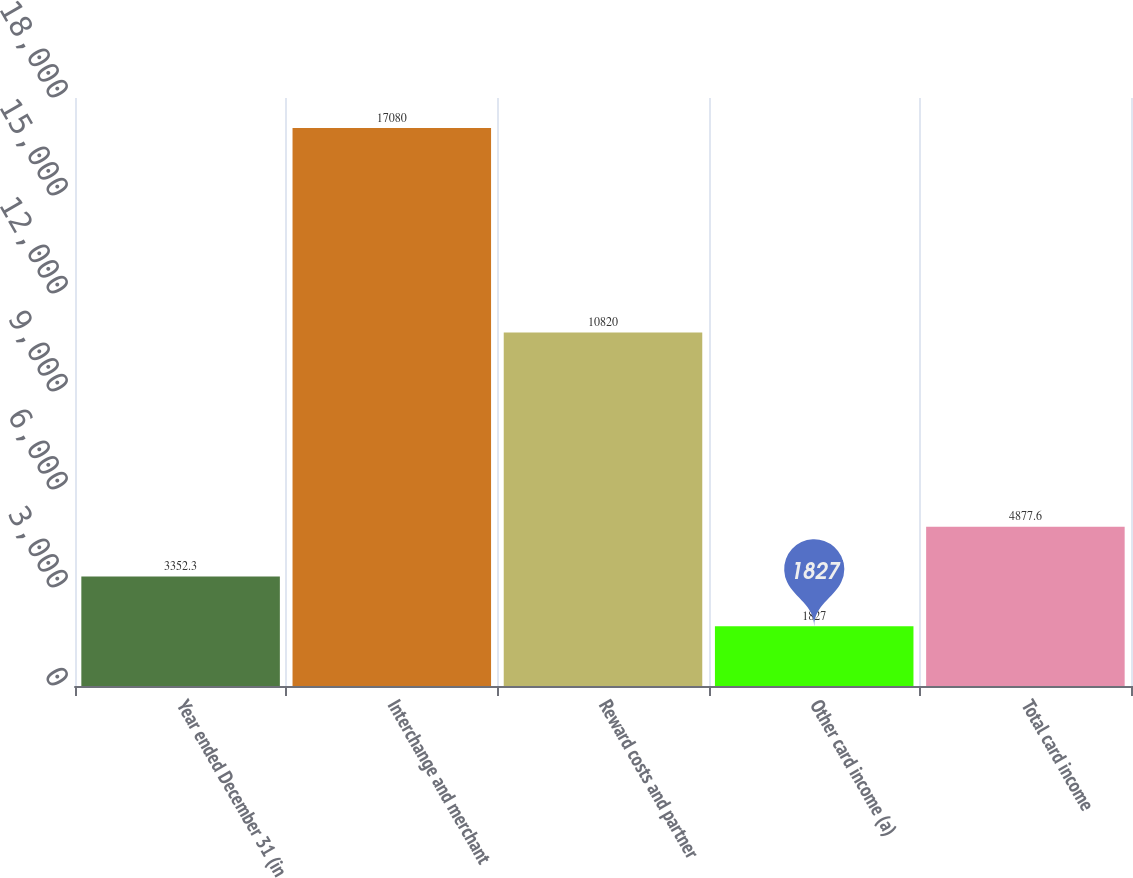<chart> <loc_0><loc_0><loc_500><loc_500><bar_chart><fcel>Year ended December 31 (in<fcel>Interchange and merchant<fcel>Reward costs and partner<fcel>Other card income (a)<fcel>Total card income<nl><fcel>3352.3<fcel>17080<fcel>10820<fcel>1827<fcel>4877.6<nl></chart> 